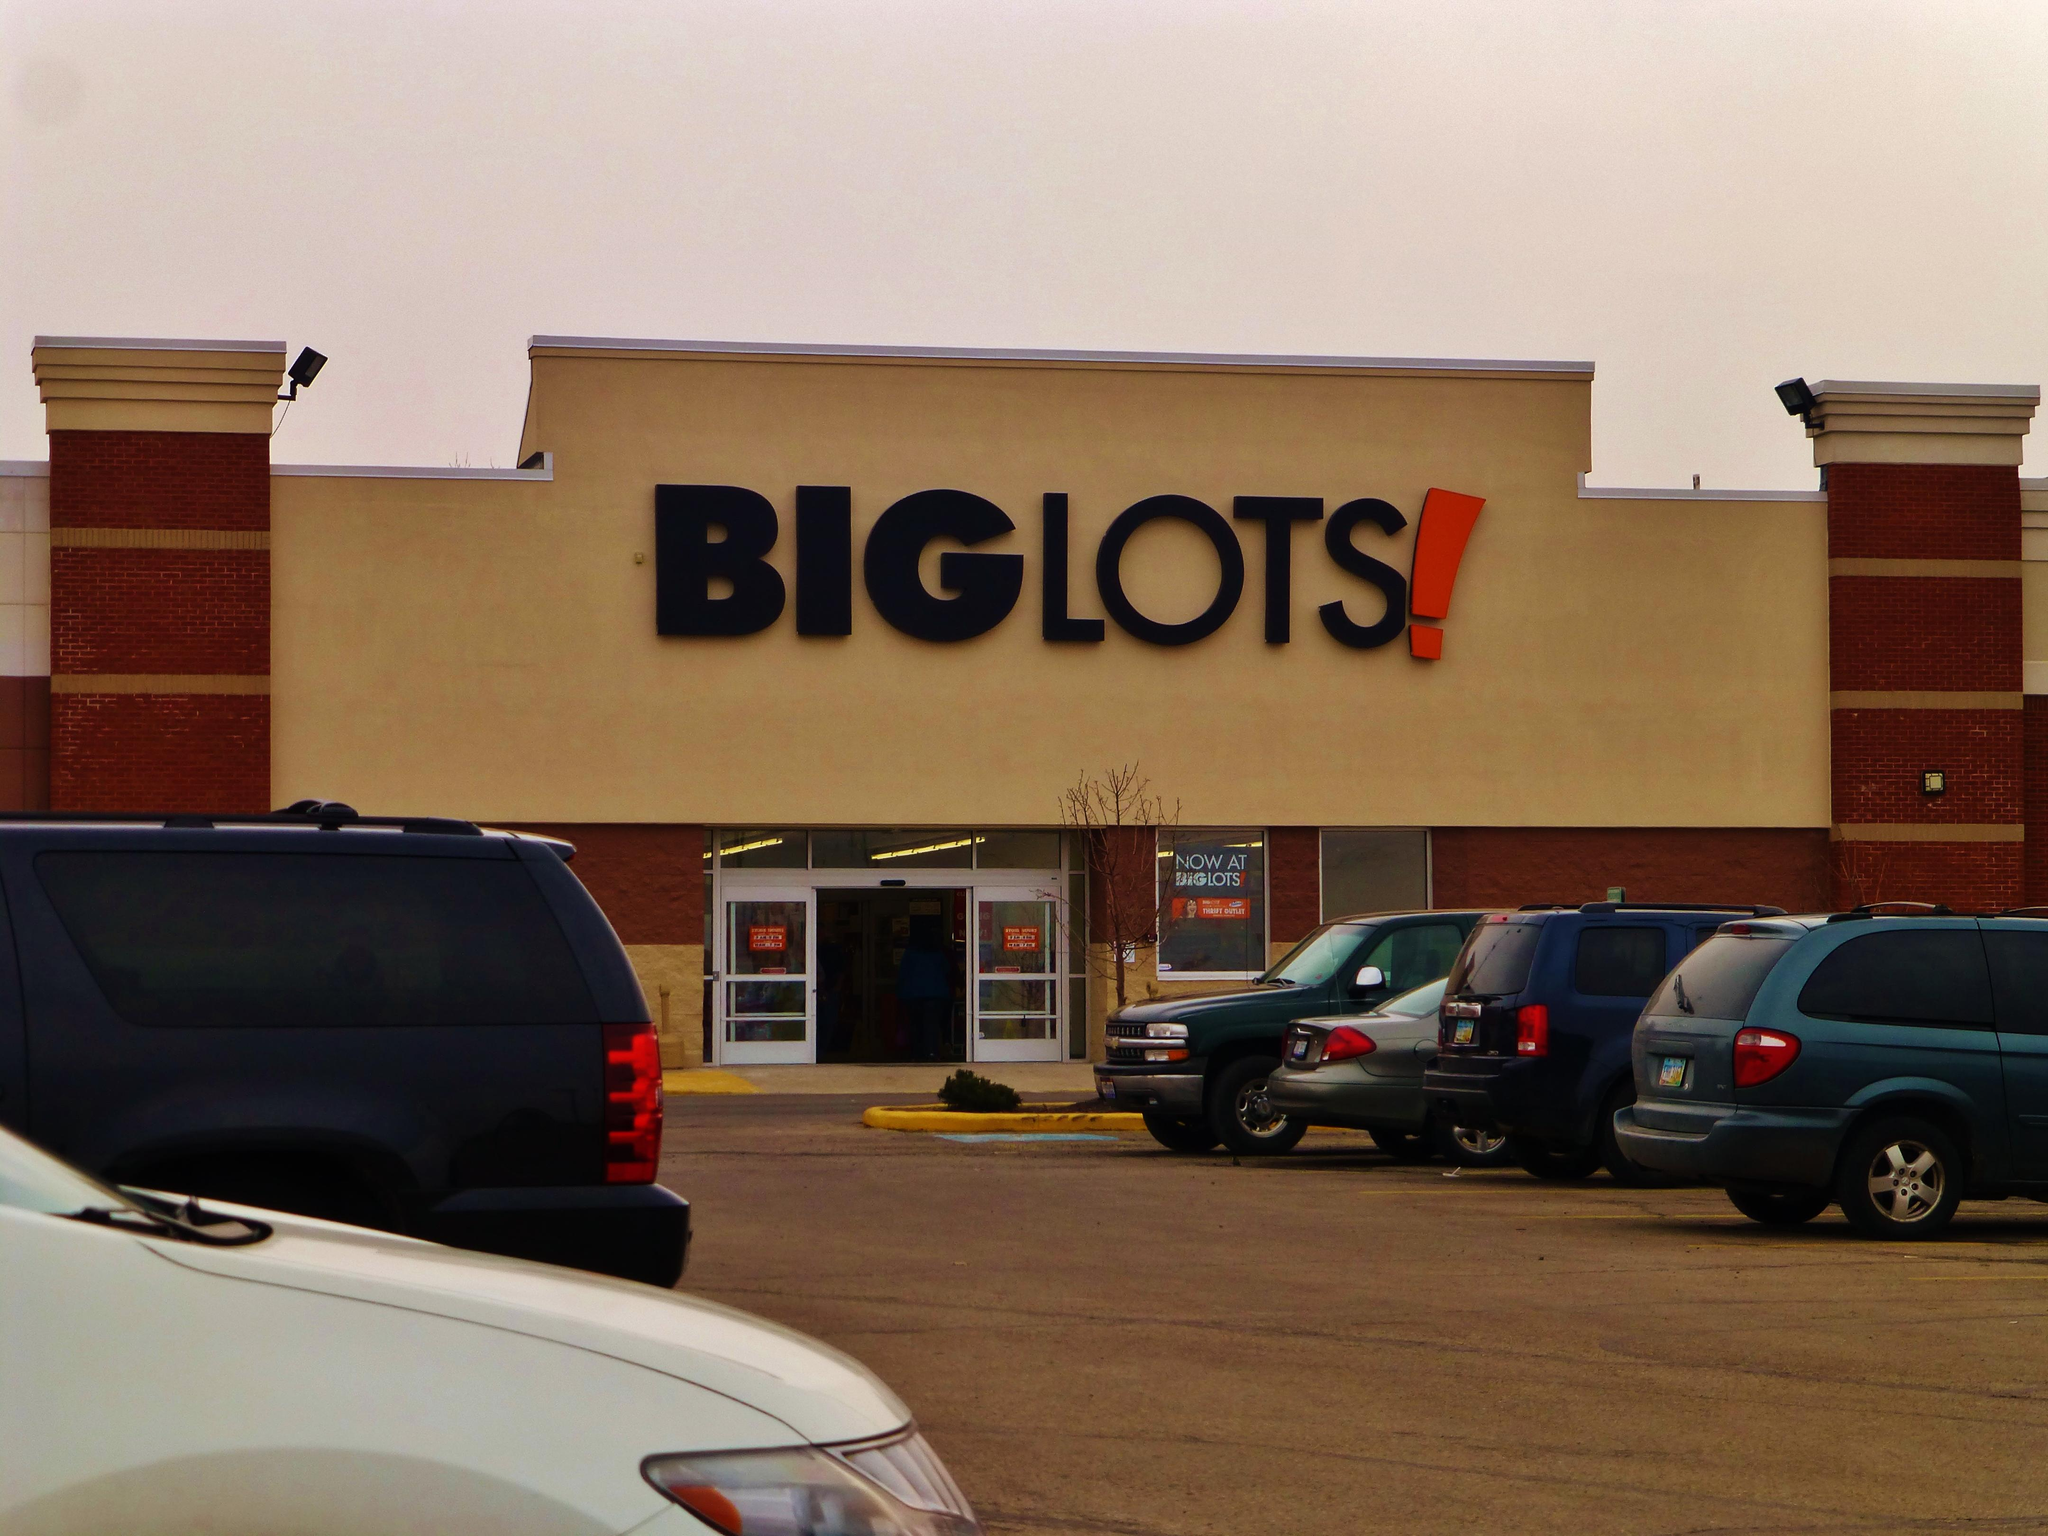What type of establishment is shown in the image? There is a store in the image. What can be seen on the store's exterior? There is a window and posters on the doors and window. What is visible in the sky in the image? The sky is visible in the image. What type of illumination is present in the image? There are lights visible in the image. What else can be seen in the image besides the store? There are vehicles in the image. What title does the arm hold in the image? There is no arm or title present in the image. 